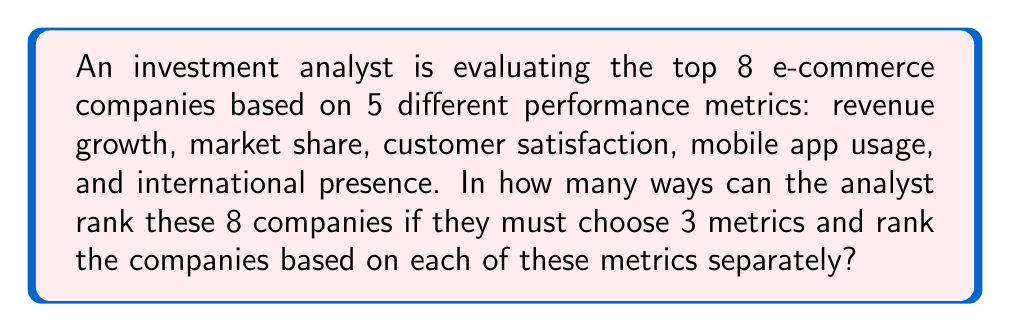Provide a solution to this math problem. Let's break this down step-by-step:

1) First, we need to choose 3 metrics out of the 5 available. This is a combination problem. The number of ways to choose 3 items from 5 is given by the combination formula:

   $$\binom{5}{3} = \frac{5!}{3!(5-3)!} = \frac{5!}{3!2!} = 10$$

2) Now, for each of these 3 chosen metrics, we need to rank all 8 companies. Ranking 8 companies is a permutation of 8 items, which is simply 8!.

3) We need to do this ranking for each of the 3 chosen metrics. Therefore, we multiply 8! by itself 3 times:

   $$(8!)^3$$

4) Finally, we need to consider all possible combinations of metrics. For each combination of 3 metrics (of which there are 10), we have $(8!)^3$ ways to rank the companies.

5) Therefore, the total number of ways to rank the companies is:

   $$10 \cdot (8!)^3$$

6) Calculating this:
   
   $$10 \cdot (40320)^3 = 10 \cdot 65,549,251,248,128,000 = 655,492,512,481,280,000$$

This extremely large number demonstrates the complexity of analyzing multiple companies across various metrics, highlighting the importance of focused analysis in the investment analyst's work.
Answer: 655,492,512,481,280,000 